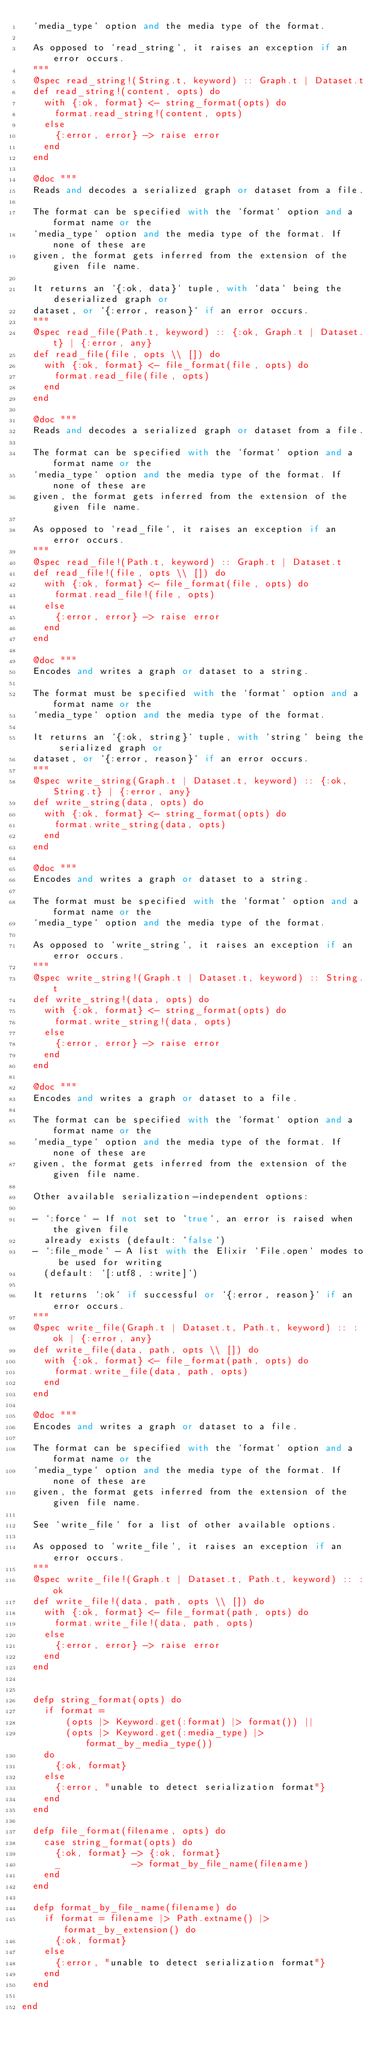Convert code to text. <code><loc_0><loc_0><loc_500><loc_500><_Elixir_>  `media_type` option and the media type of the format.

  As opposed to `read_string`, it raises an exception if an error occurs.
  """
  @spec read_string!(String.t, keyword) :: Graph.t | Dataset.t
  def read_string!(content, opts) do
    with {:ok, format} <- string_format(opts) do
      format.read_string!(content, opts)
    else
      {:error, error} -> raise error
    end
  end

  @doc """
  Reads and decodes a serialized graph or dataset from a file.

  The format can be specified with the `format` option and a format name or the 
  `media_type` option and the media type of the format. If none of these are 
  given, the format gets inferred from the extension of the given file name. 

  It returns an `{:ok, data}` tuple, with `data` being the deserialized graph or
  dataset, or `{:error, reason}` if an error occurs.
  """
  @spec read_file(Path.t, keyword) :: {:ok, Graph.t | Dataset.t} | {:error, any}
  def read_file(file, opts \\ []) do
    with {:ok, format} <- file_format(file, opts) do
      format.read_file(file, opts)
    end
  end

  @doc """
  Reads and decodes a serialized graph or dataset from a file.

  The format can be specified with the `format` option and a format name or the 
  `media_type` option and the media type of the format. If none of these are 
  given, the format gets inferred from the extension of the given file name. 

  As opposed to `read_file`, it raises an exception if an error occurs.
  """
  @spec read_file!(Path.t, keyword) :: Graph.t | Dataset.t
  def read_file!(file, opts \\ []) do
    with {:ok, format} <- file_format(file, opts) do
      format.read_file!(file, opts)
    else
      {:error, error} -> raise error
    end
  end

  @doc """
  Encodes and writes a graph or dataset to a string.

  The format must be specified with the `format` option and a format name or the 
  `media_type` option and the media type of the format.

  It returns an `{:ok, string}` tuple, with `string` being the serialized graph or
  dataset, or `{:error, reason}` if an error occurs.
  """
  @spec write_string(Graph.t | Dataset.t, keyword) :: {:ok, String.t} | {:error, any}
  def write_string(data, opts) do
    with {:ok, format} <- string_format(opts) do
      format.write_string(data, opts)
    end
  end

  @doc """
  Encodes and writes a graph or dataset to a string.

  The format must be specified with the `format` option and a format name or the 
  `media_type` option and the media type of the format.

  As opposed to `write_string`, it raises an exception if an error occurs.
  """
  @spec write_string!(Graph.t | Dataset.t, keyword) :: String.t
  def write_string!(data, opts) do
    with {:ok, format} <- string_format(opts) do
      format.write_string!(data, opts)
    else
      {:error, error} -> raise error
    end
  end

  @doc """
  Encodes and writes a graph or dataset to a file.

  The format can be specified with the `format` option and a format name or the
  `media_type` option and the media type of the format. If none of these are
  given, the format gets inferred from the extension of the given file name.

  Other available serialization-independent options:

  - `:force` - If not set to `true`, an error is raised when the given file
    already exists (default: `false`)
  - `:file_mode` - A list with the Elixir `File.open` modes to be used for writing
    (default: `[:utf8, :write]`)

  It returns `:ok` if successful or `{:error, reason}` if an error occurs.
  """
  @spec write_file(Graph.t | Dataset.t, Path.t, keyword) :: :ok | {:error, any}
  def write_file(data, path, opts \\ []) do
    with {:ok, format} <- file_format(path, opts) do
      format.write_file(data, path, opts)
    end
  end

  @doc """
  Encodes and writes a graph or dataset to a file.

  The format can be specified with the `format` option and a format name or the
  `media_type` option and the media type of the format. If none of these are
  given, the format gets inferred from the extension of the given file name.

  See `write_file` for a list of other available options.

  As opposed to `write_file`, it raises an exception if an error occurs.
  """
  @spec write_file!(Graph.t | Dataset.t, Path.t, keyword) :: :ok
  def write_file!(data, path, opts \\ []) do
    with {:ok, format} <- file_format(path, opts) do
      format.write_file!(data, path, opts)
    else
      {:error, error} -> raise error
    end
  end


  defp string_format(opts) do
    if format =
        (opts |> Keyword.get(:format) |> format()) ||
        (opts |> Keyword.get(:media_type) |> format_by_media_type())
    do
      {:ok, format}
    else
      {:error, "unable to detect serialization format"}
    end
  end

  defp file_format(filename, opts) do
    case string_format(opts) do
      {:ok, format} -> {:ok, format}
      _             -> format_by_file_name(filename)
    end
  end

  defp format_by_file_name(filename) do
    if format = filename |> Path.extname() |> format_by_extension() do
      {:ok, format}
    else
      {:error, "unable to detect serialization format"}
    end
  end

end
</code> 